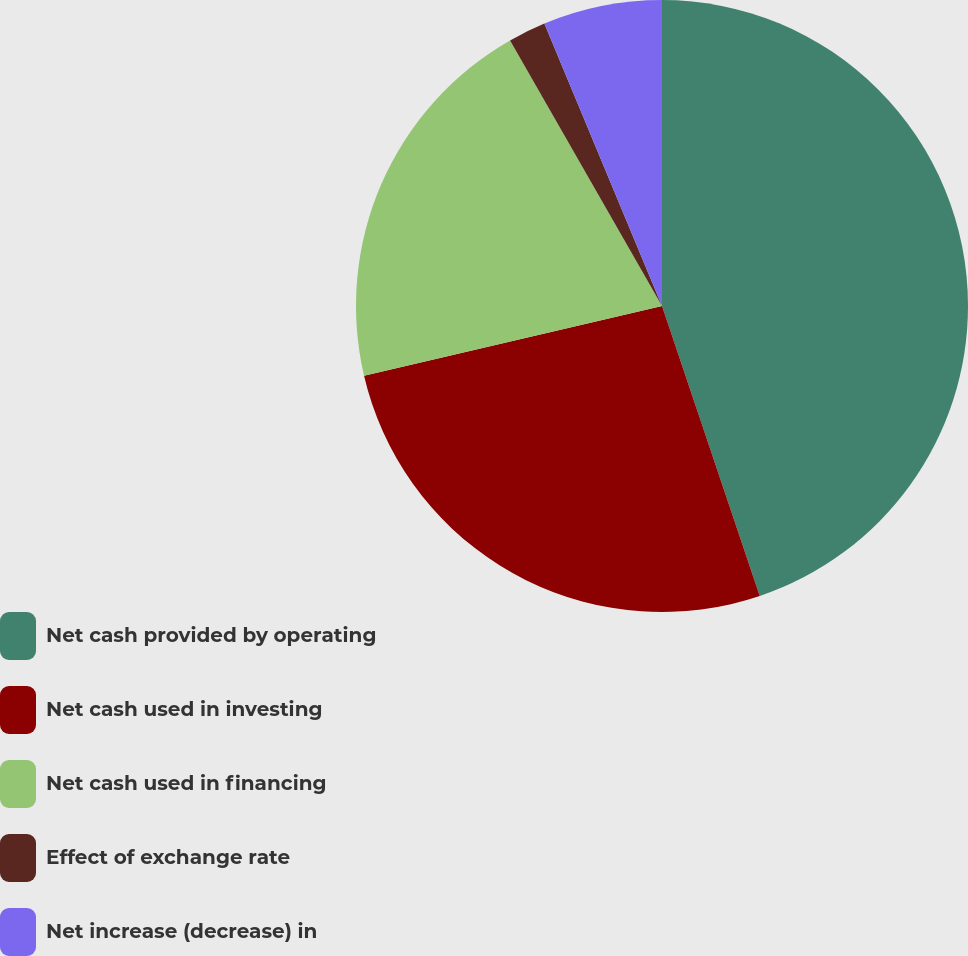<chart> <loc_0><loc_0><loc_500><loc_500><pie_chart><fcel>Net cash provided by operating<fcel>Net cash used in investing<fcel>Net cash used in financing<fcel>Effect of exchange rate<fcel>Net increase (decrease) in<nl><fcel>44.83%<fcel>26.52%<fcel>20.39%<fcel>1.99%<fcel>6.28%<nl></chart> 